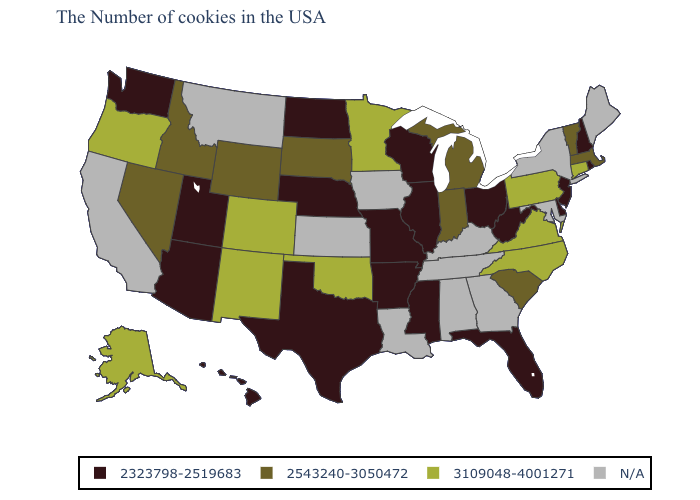Among the states that border Arkansas , which have the highest value?
Quick response, please. Oklahoma. Which states hav the highest value in the South?
Concise answer only. Virginia, North Carolina, Oklahoma. Is the legend a continuous bar?
Be succinct. No. Does Virginia have the highest value in the USA?
Write a very short answer. Yes. Does Illinois have the lowest value in the MidWest?
Give a very brief answer. Yes. What is the value of Arkansas?
Be succinct. 2323798-2519683. Name the states that have a value in the range 2323798-2519683?
Quick response, please. Rhode Island, New Hampshire, New Jersey, Delaware, West Virginia, Ohio, Florida, Wisconsin, Illinois, Mississippi, Missouri, Arkansas, Nebraska, Texas, North Dakota, Utah, Arizona, Washington, Hawaii. Name the states that have a value in the range 3109048-4001271?
Be succinct. Connecticut, Pennsylvania, Virginia, North Carolina, Minnesota, Oklahoma, Colorado, New Mexico, Oregon, Alaska. Among the states that border Montana , which have the lowest value?
Concise answer only. North Dakota. Among the states that border Arizona , which have the highest value?
Quick response, please. Colorado, New Mexico. Does the first symbol in the legend represent the smallest category?
Quick response, please. Yes. Does the map have missing data?
Quick response, please. Yes. Which states have the lowest value in the West?
Write a very short answer. Utah, Arizona, Washington, Hawaii. Does the first symbol in the legend represent the smallest category?
Be succinct. Yes. 